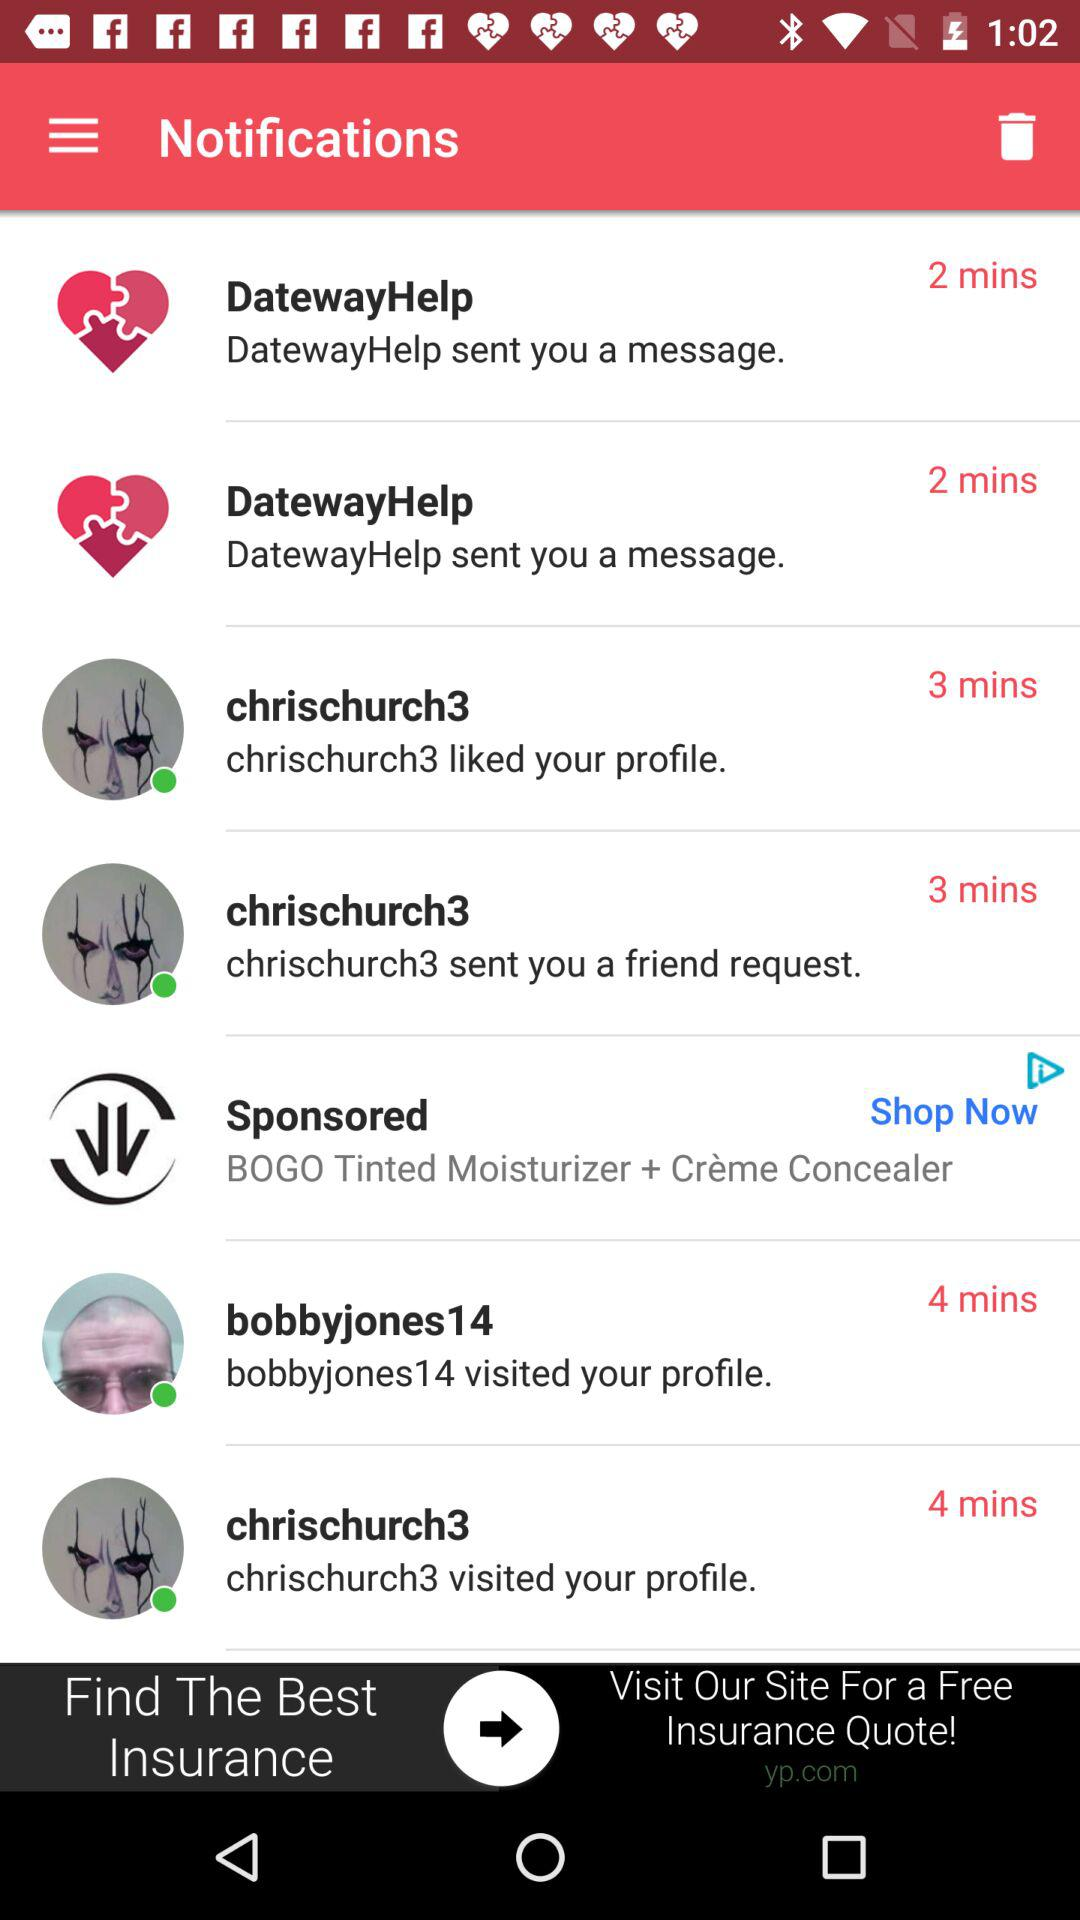How many minutes ago was the most recent notification sent?
Answer the question using a single word or phrase. 2 mins 